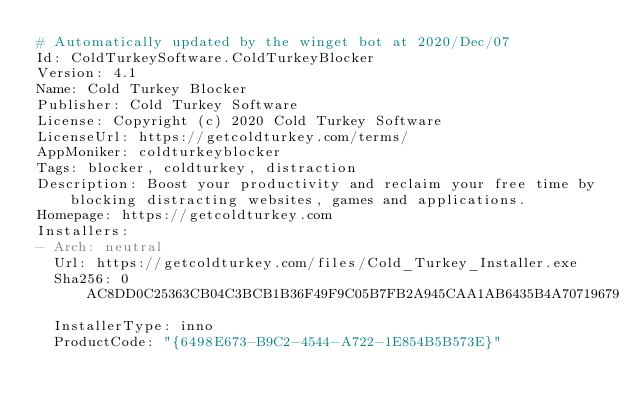Convert code to text. <code><loc_0><loc_0><loc_500><loc_500><_YAML_># Automatically updated by the winget bot at 2020/Dec/07
Id: ColdTurkeySoftware.ColdTurkeyBlocker
Version: 4.1
Name: Cold Turkey Blocker
Publisher: Cold Turkey Software
License: Copyright (c) 2020 Cold Turkey Software
LicenseUrl: https://getcoldturkey.com/terms/
AppMoniker: coldturkeyblocker
Tags: blocker, coldturkey, distraction
Description: Boost your productivity and reclaim your free time by blocking distracting websites, games and applications.
Homepage: https://getcoldturkey.com
Installers:
- Arch: neutral
  Url: https://getcoldturkey.com/files/Cold_Turkey_Installer.exe
  Sha256: 0AC8DD0C25363CB04C3BCB1B36F49F9C05B7FB2A945CAA1AB6435B4A70719679
  InstallerType: inno
  ProductCode: "{6498E673-B9C2-4544-A722-1E854B5B573E}"
</code> 